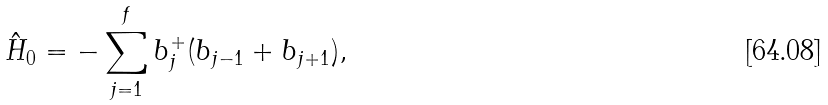Convert formula to latex. <formula><loc_0><loc_0><loc_500><loc_500>\hat { H } _ { 0 } = - \sum _ { j = 1 } ^ { f } b _ { j } ^ { + } ( b _ { j - 1 } + b _ { j + 1 } ) ,</formula> 